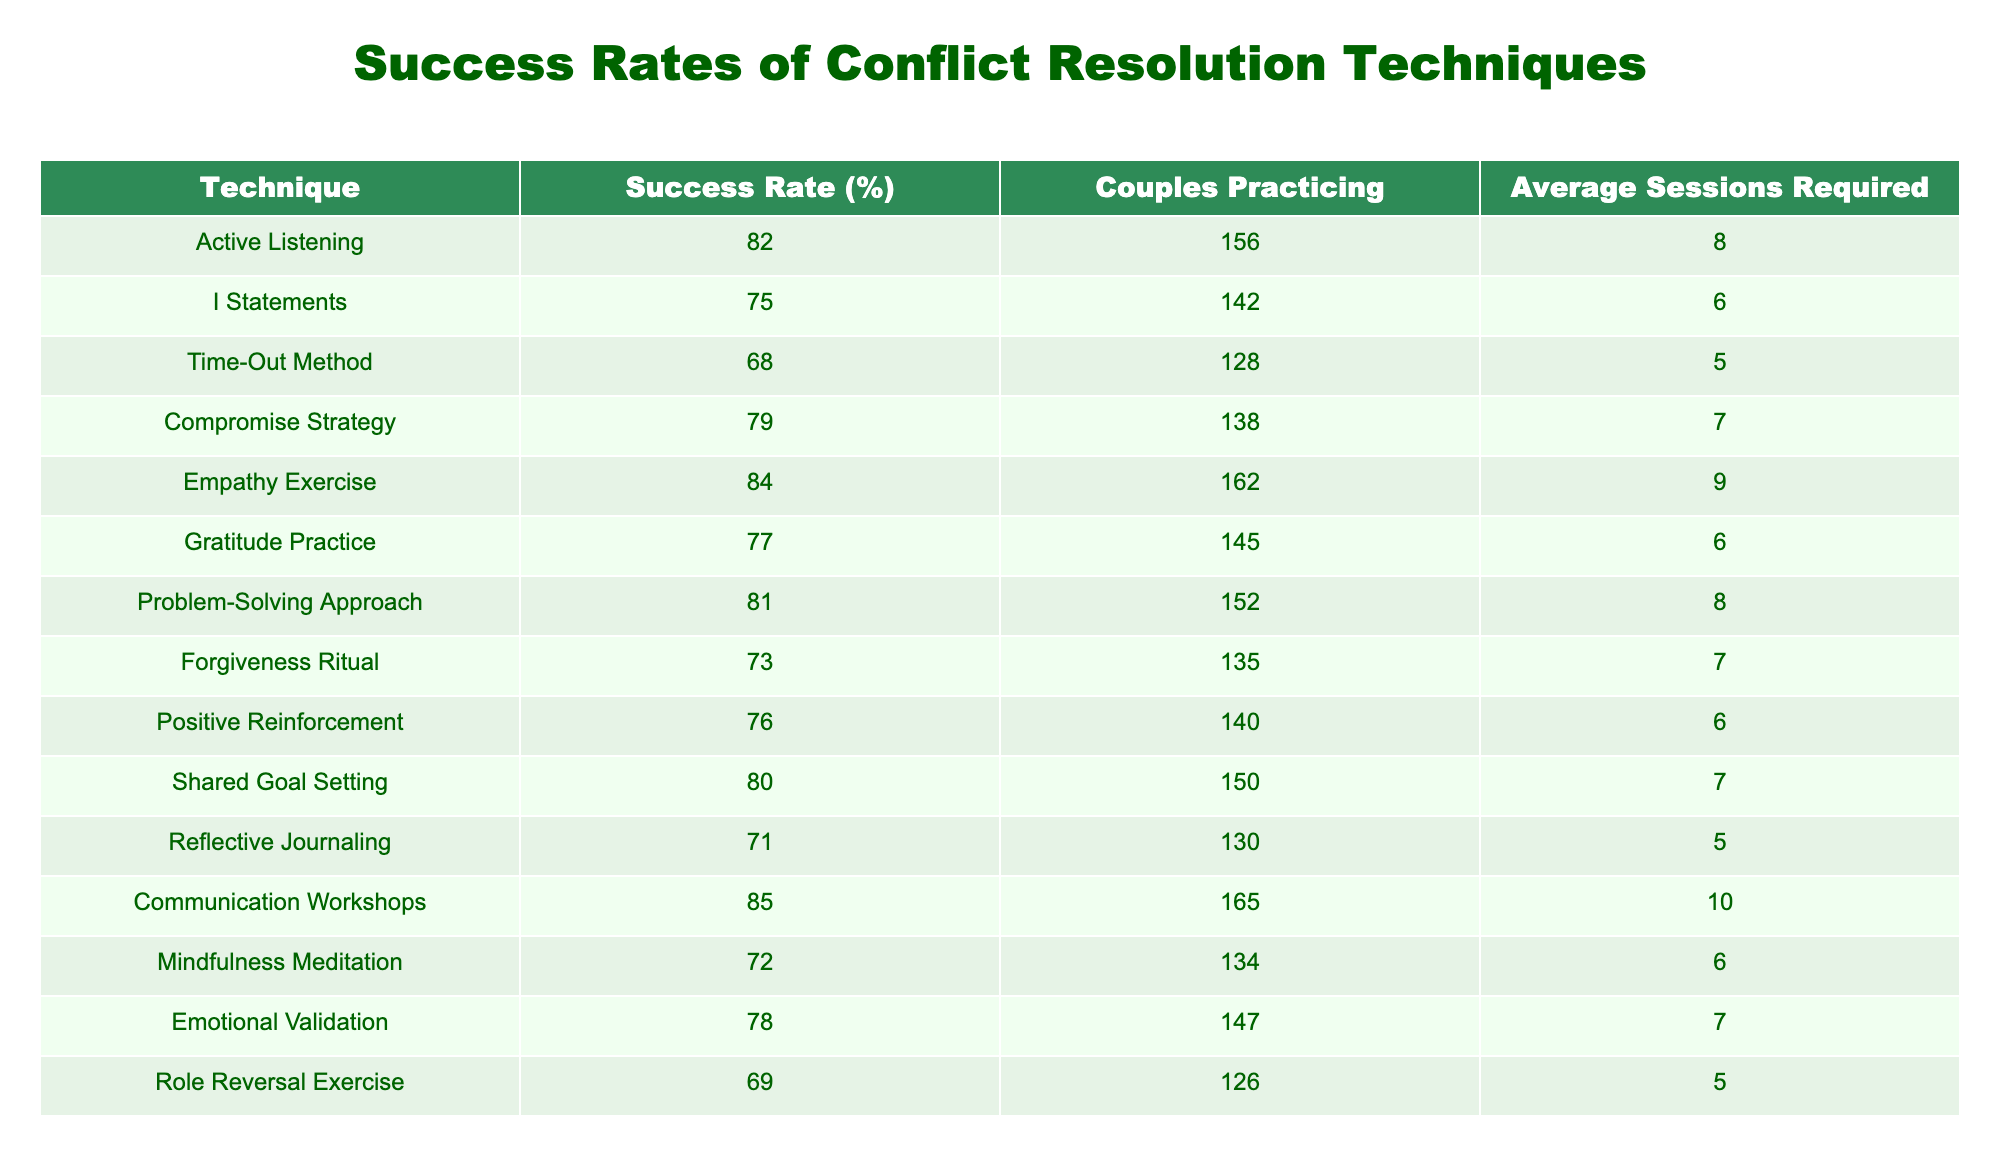What is the success rate of the Empathy Exercise? The success rate for the Empathy Exercise is listed directly in the table under the Success Rate (%) column. By looking at the corresponding row for the Empathy Exercise, we see that the value is 84%.
Answer: 84% Which conflict resolution technique has the lowest success rate? To find the technique with the lowest success rate, we compare the values in the Success Rate (%) column. The lowest value is 68%, which corresponds to the Time-Out Method.
Answer: Time-Out Method What is the average success rate of techniques that require 6 sessions? The techniques that require 6 sessions are "I" Statements, Gratitude Practice, Positive Reinforcement, and Mindfulness Meditation with success rates of 75%, 77%, 76%, and 72% respectively. To find the average, we sum these values (75 + 77 + 76 + 72 = 300) and divide by the number of techniques (4). Therefore, the average success rate is 300 / 4 = 75%.
Answer: 75% Do more couples practicing a technique lead to a higher success rate? Analyzing the table, the success rates do not consistently increase with the number of couples practicing. For example, the Communication Workshops have the highest number of couples (165), yet a lower success rate (85%) compared to the Empathy Exercise (84%) with fewer couples (162). Thus, the relationship is not definitive.
Answer: No What is the relationship between session count and success rate for the Conflict Resolution Techniques? By examining the table, we can observe the average sessions required for each technique and their corresponding success rates. A few techniques like Emotional Validation (7 sessions, 78%) and other techniques maintain varying rates. Ultimately, no clear direct correlation can be determined solely with the provided data, implying that more extensive analysis might be needed.
Answer: No clear relationship 